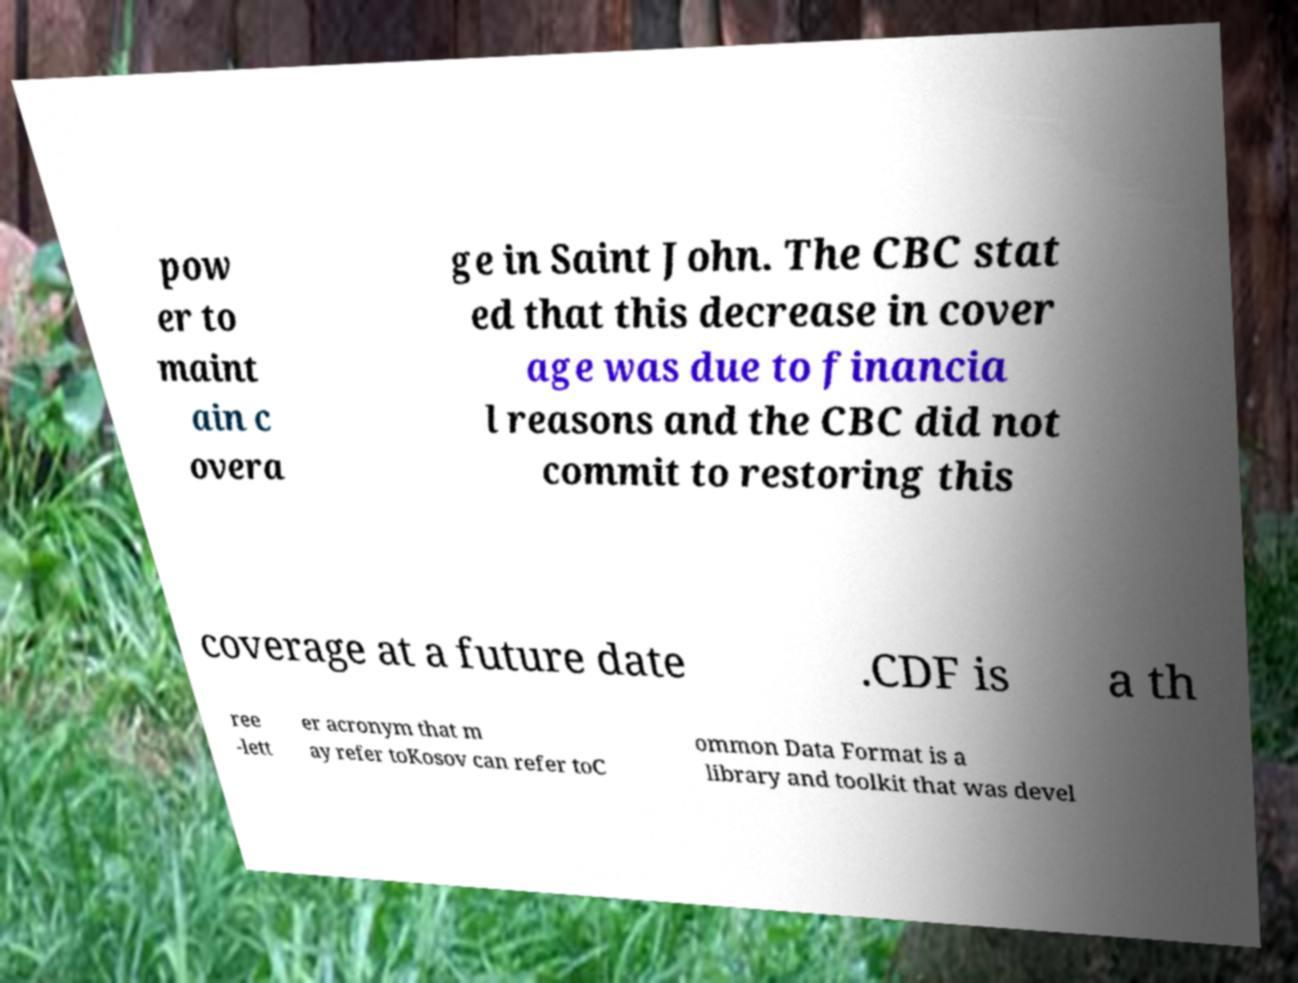Could you extract and type out the text from this image? pow er to maint ain c overa ge in Saint John. The CBC stat ed that this decrease in cover age was due to financia l reasons and the CBC did not commit to restoring this coverage at a future date .CDF is a th ree -lett er acronym that m ay refer toKosov can refer toC ommon Data Format is a library and toolkit that was devel 